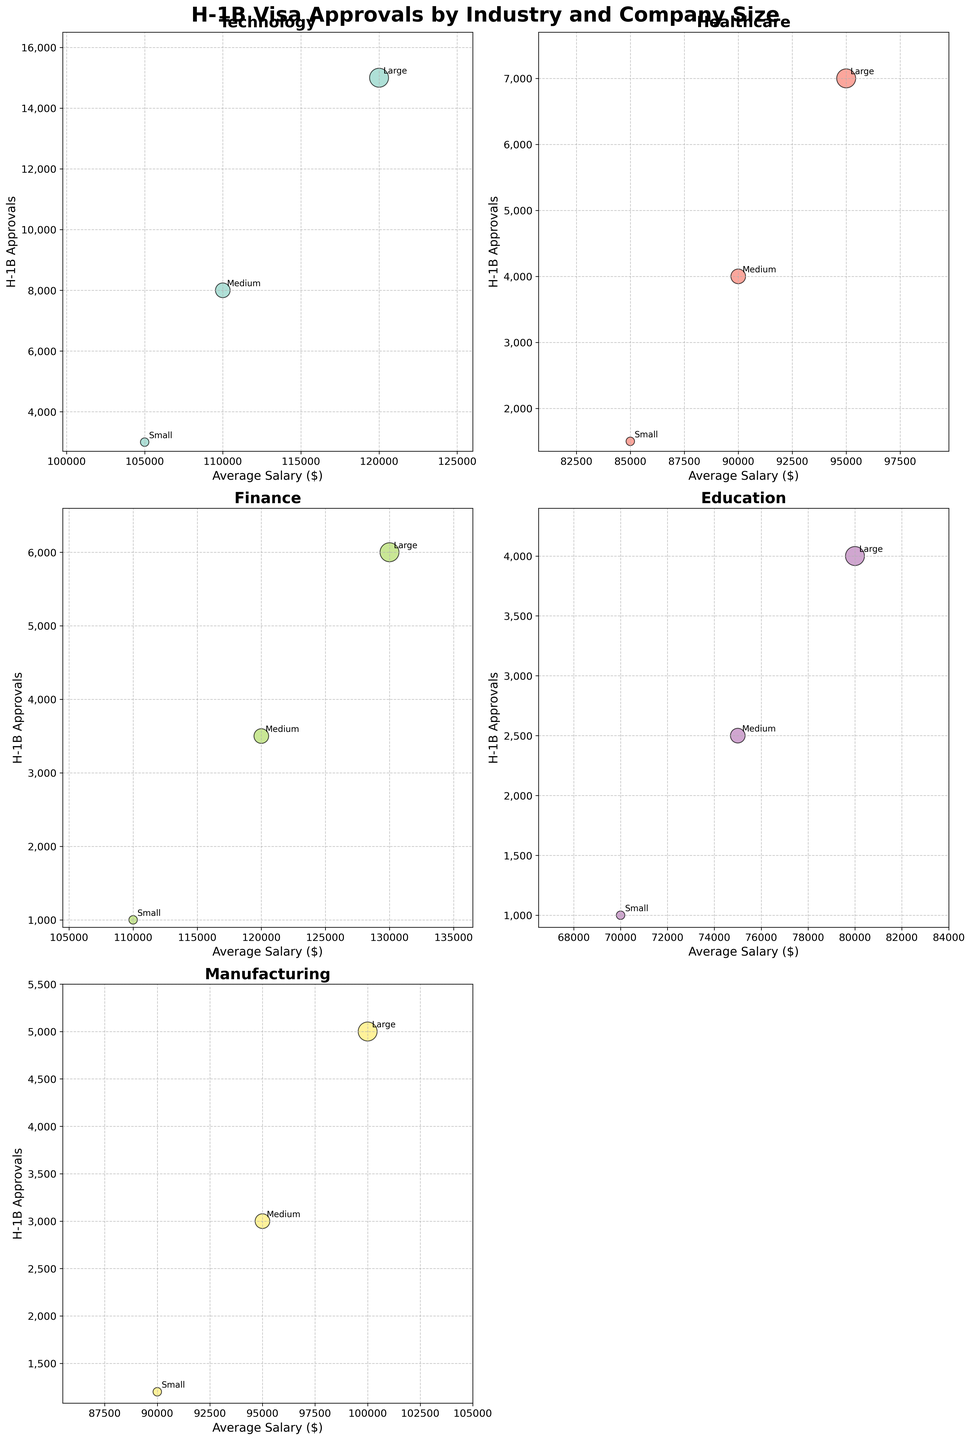What is the title of the subplot? The title of the figure is displayed at the top of the subplot, summarizing its content. The title is "H-1B Visa Approvals by Industry and Company Size".
Answer: H-1B Visa Approvals by Industry and Company Size Which industry has the highest number of H-1B approvals for large companies? By looking at the y-axis values for the 'Large' company size across different industries, the Technology sector has the highest number of H-1B approvals with 15,000.
Answer: Technology Which industry has the lowest average salary for medium-size companies? To find this, we look at the x-axis values for the 'Medium' company size across different industries. The Education sector has an average salary of $75,000, the lowest among medium-size companies.
Answer: Education How many industries are represented in the subplot? Each scatter plot within the subplot represents a different industry. By counting the different subplots, we see there are five industries represented.
Answer: Five Which company sizes are labeled in each subplot? Each bubble within a subplot is labeled with the company size, denoted as 'Small', 'Medium', or 'Large'. Each industry subplot contains data points for these three company sizes.
Answer: Small, Medium, Large In the Finance industry, which company size has the highest average salary and what is it? By examining the Finance subplot, we look at the x-axis values. The 'Large' company size bubble has the highest average salary at $130,000.
Answer: Large, $130,000 Compare the number of H-1B approvals between Medium-sized companies in Healthcare and Manufacturing. Which has more and by how much? In the Healthcare subplot, Medium-sized companies have 4,000 approvals. In the Manufacturing subplot, Medium-sized companies have 3,000 approvals. So, Healthcare has more by 1,000 approvals.
Answer: Healthcare by 1,000 What is the relationship between company size and average salary within the Technology industry? By analyzing the Technology subplot, we observe that as the company size increases from Small to Large, the average salary also increases from $105,000 to $120,000, indicating a positive relationship.
Answer: Positive relationship Which industry has the smallest bubbles and what does this signify about the company size? Small bubbles signify Small-sized companies. Observing the subplot, the Healthcare industry has the smallest bubbles indicating it has data points representing Small-sized companies.
Answer: Healthcare 